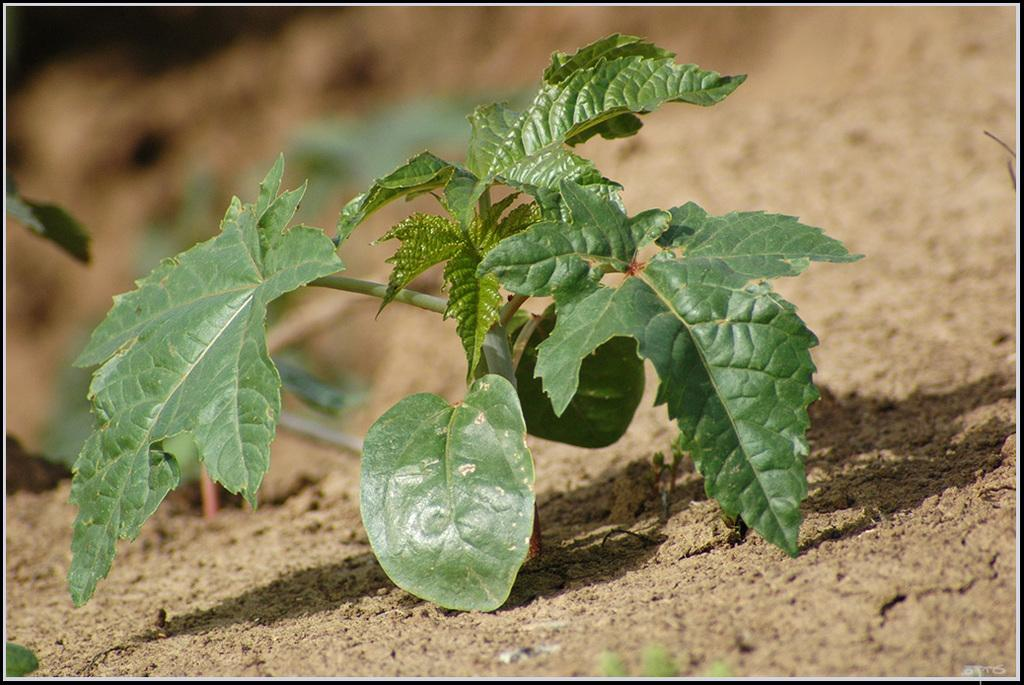What type of living organism can be seen in the image? There is a plant in the image. Where is the plant located? The plant is on the surface of the sand. What direction is the animal facing in the image? There is no animal present in the image, so it is not possible to determine the direction it might be facing. 